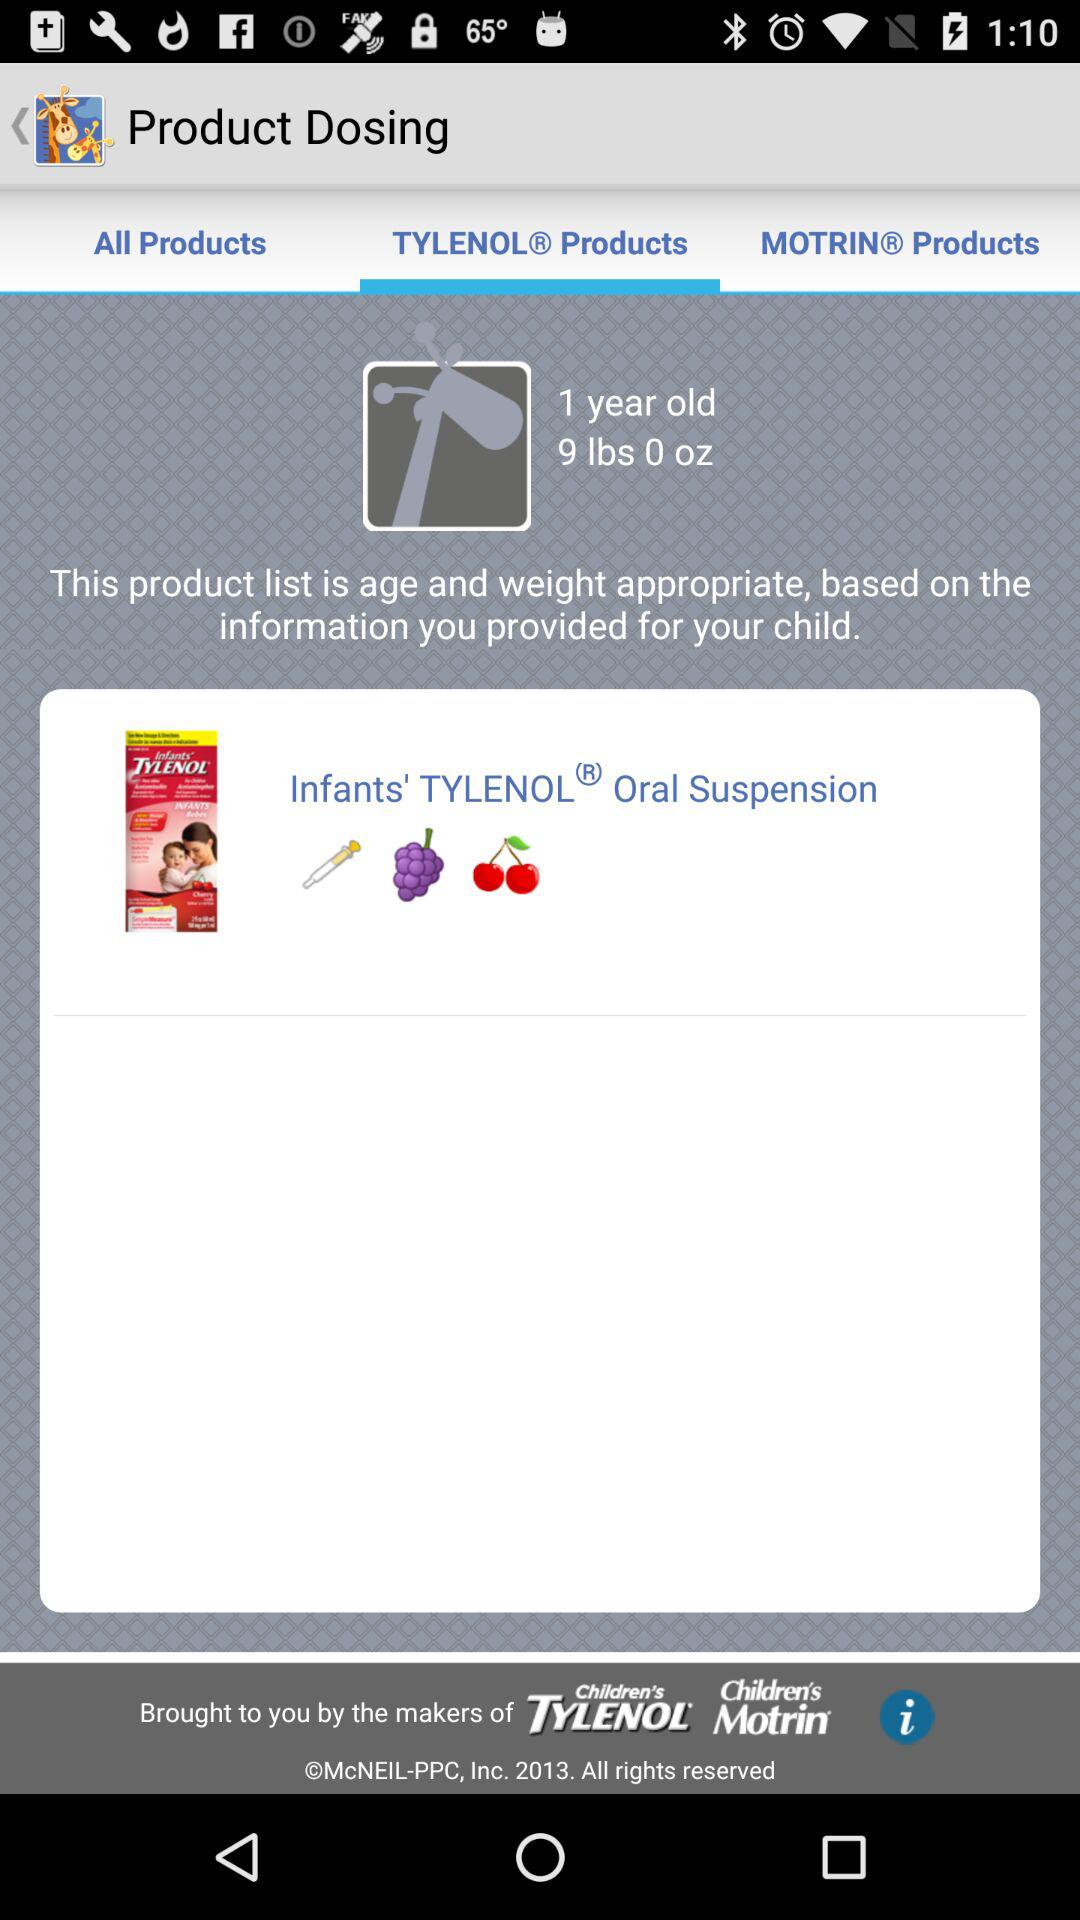What is the product name? The product name is "Infants' TYLENOL® Oral Suspension". 